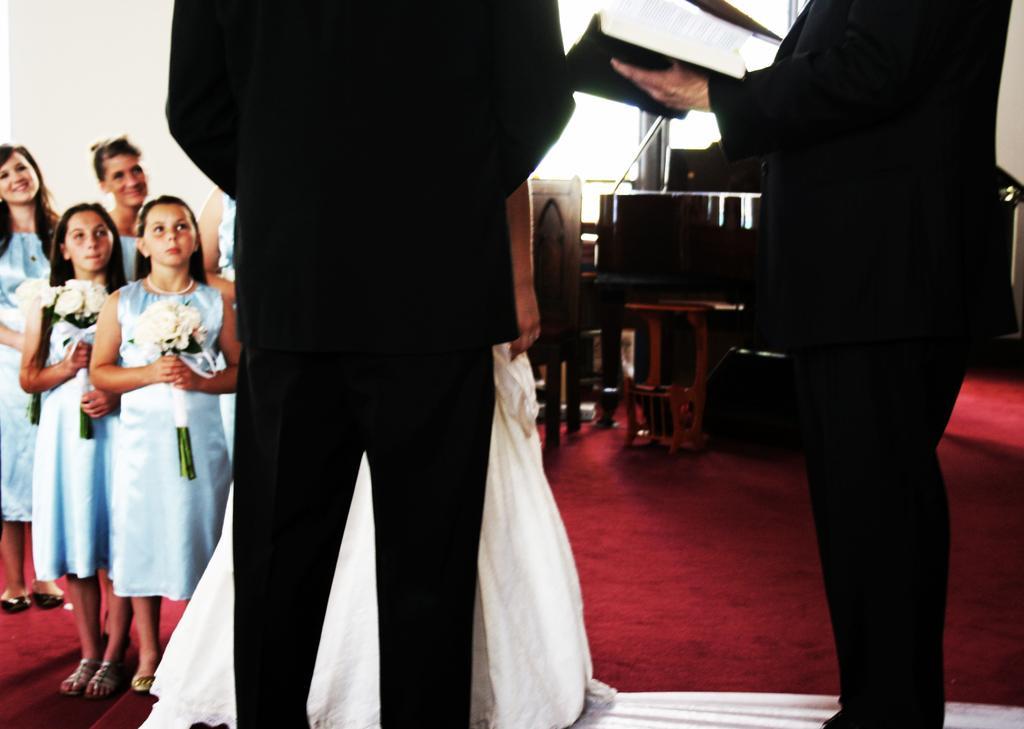Could you give a brief overview of what you see in this image? in this picture does a person standing here and there is another person standing here holding a book in his hand and there are some children and here with some flower bouquet 